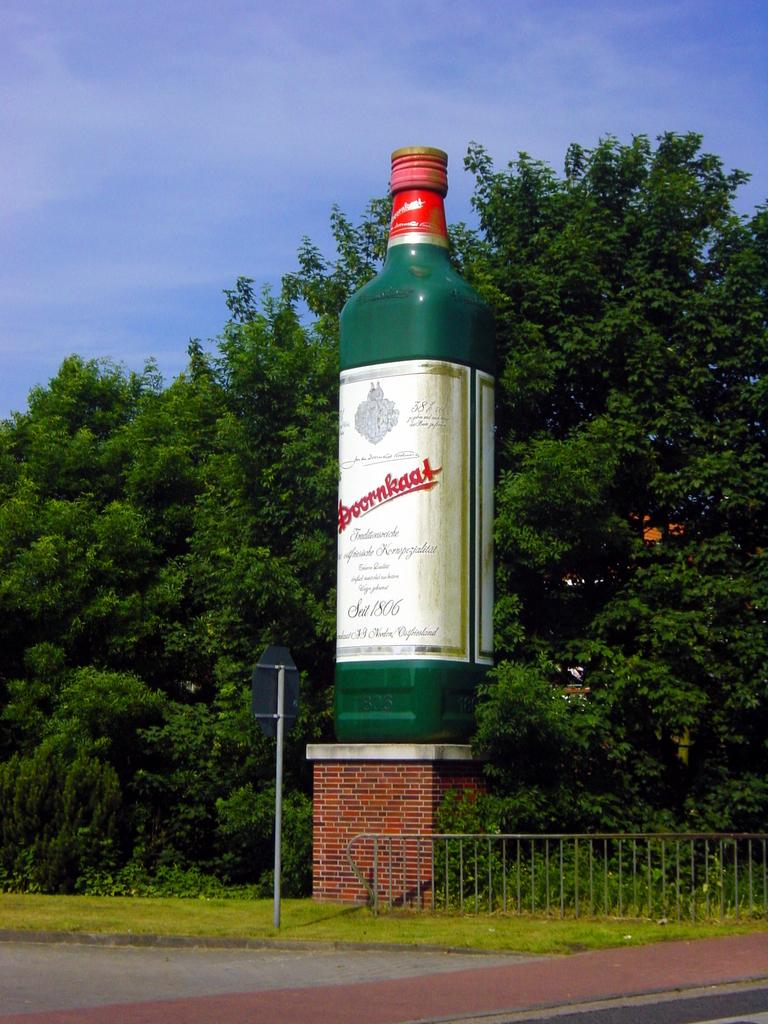<image>
Offer a succinct explanation of the picture presented. a giant statue of Doornkatt liquor bottle standing on a pedestal 